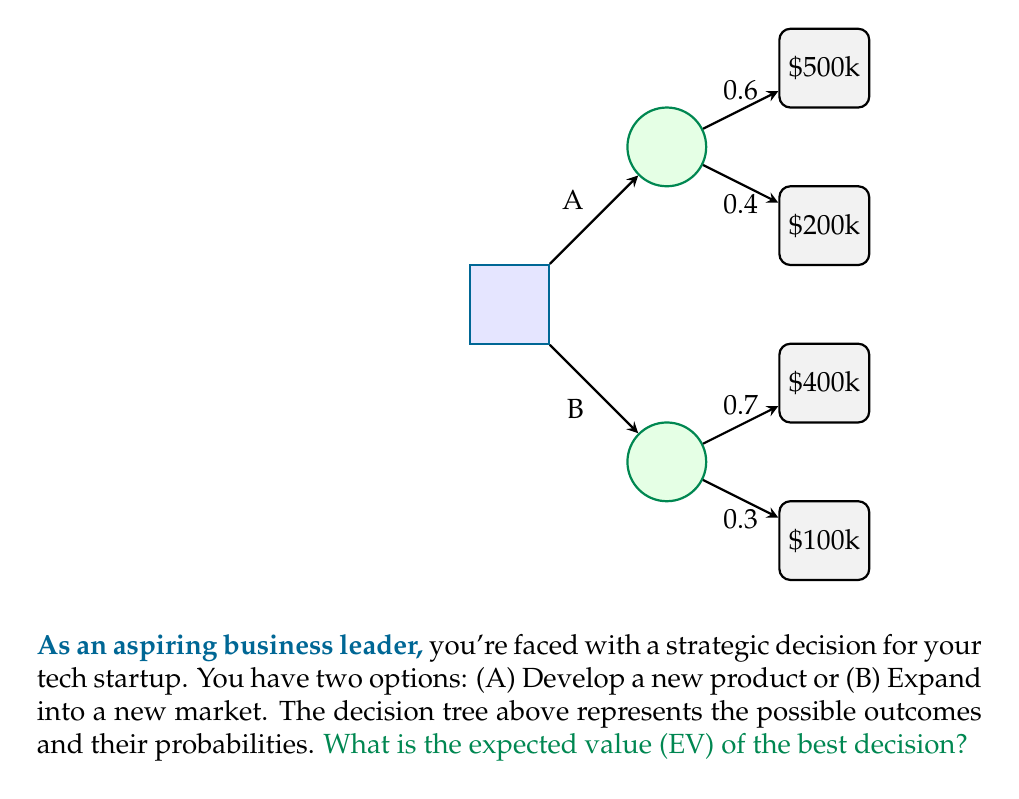Provide a solution to this math problem. To solve this problem, we need to calculate the expected value (EV) for each decision and choose the one with the higher EV. Let's break it down step-by-step:

1. Calculate EV for Decision A (Develop a new product):
   $$EV(A) = 0.6 \times \$500,000 + 0.4 \times \$200,000$$
   $$EV(A) = \$300,000 + \$80,000 = \$380,000$$

2. Calculate EV for Decision B (Expand into a new market):
   $$EV(B) = 0.7 \times \$400,000 + 0.3 \times \$100,000$$
   $$EV(B) = \$280,000 + \$30,000 = \$310,000$$

3. Compare the two EVs:
   EV(A) = $380,000
   EV(B) = $310,000

4. Choose the decision with the higher EV:
   Since EV(A) > EV(B), the best decision is to choose option A (Develop a new product).

5. The expected value of the best decision is the EV of option A:
   $$EV(\text{best decision}) = \$380,000$$

Therefore, the expected value of the best decision is $380,000.
Answer: $380,000 